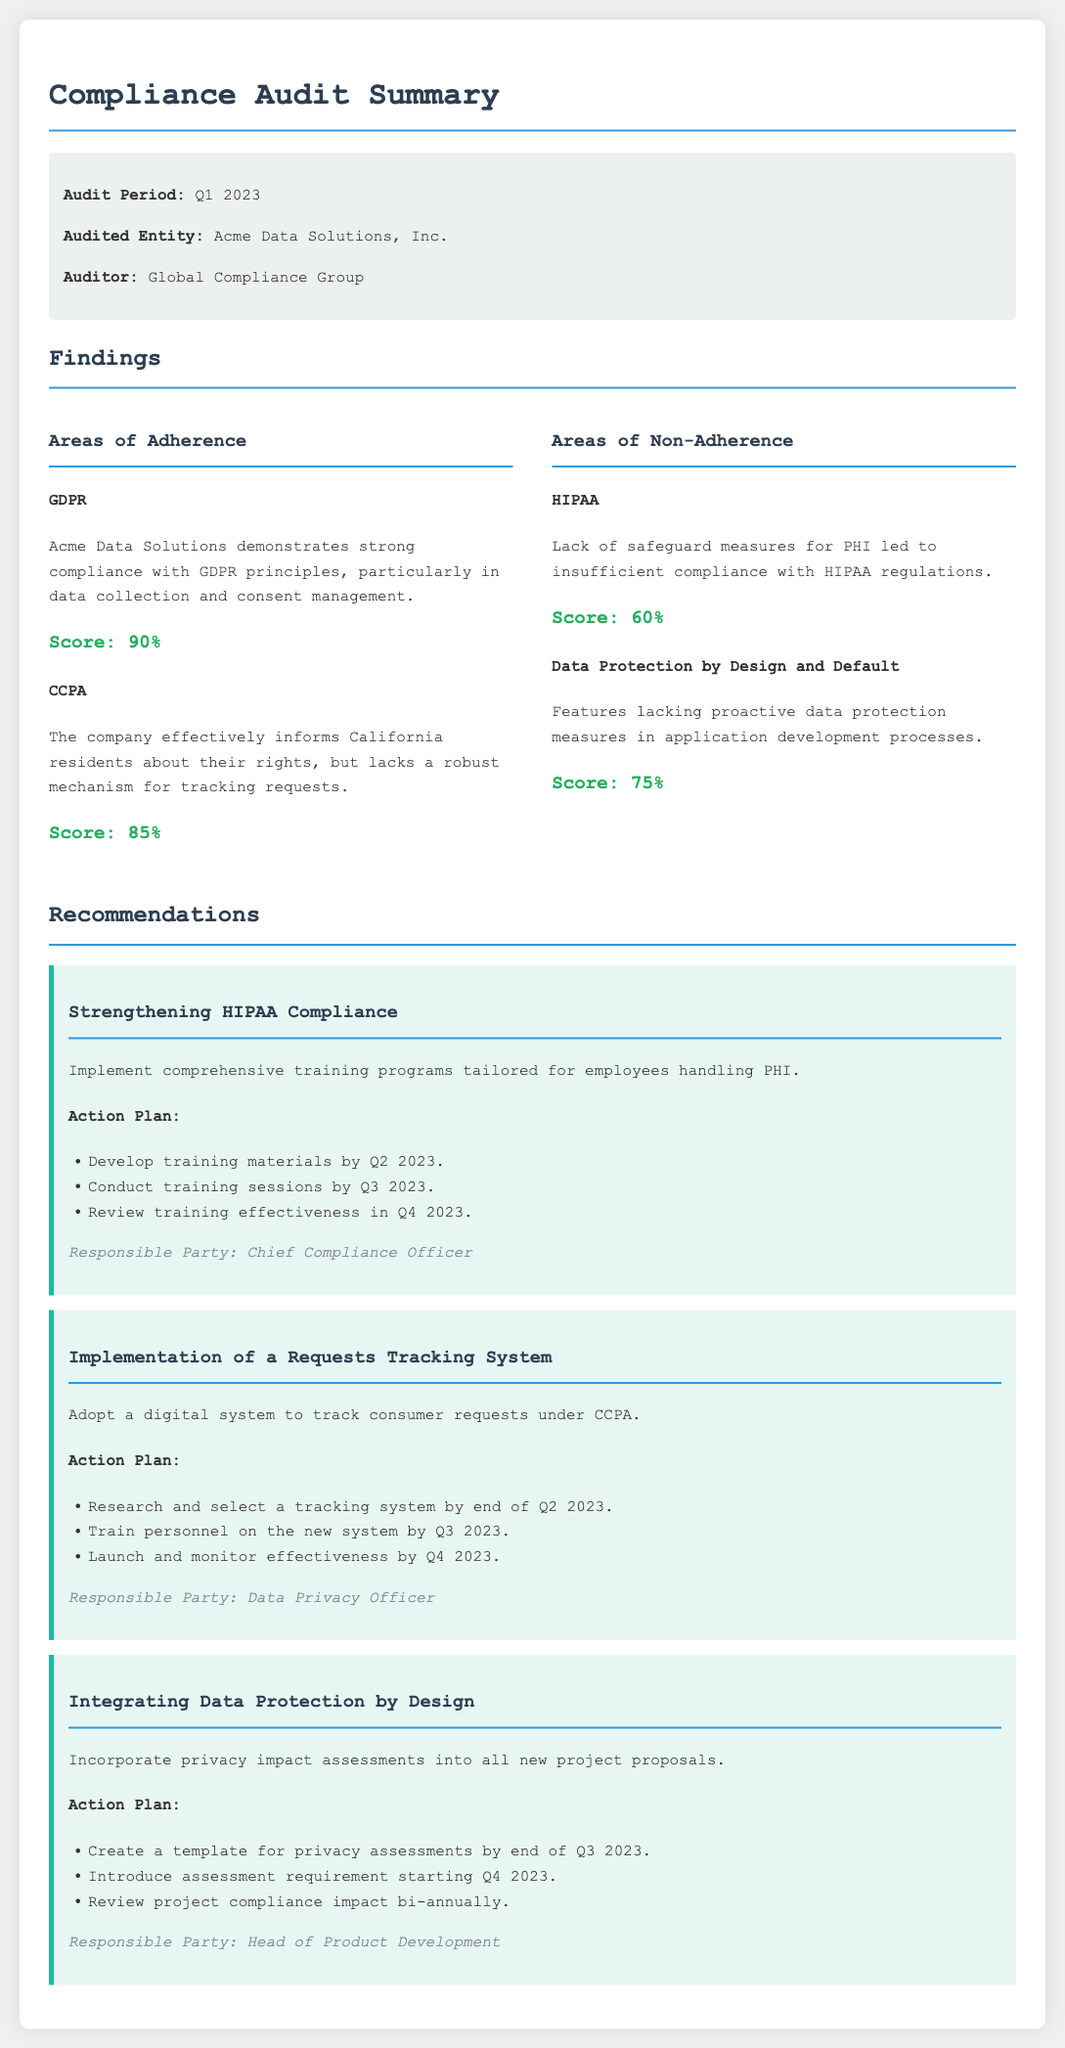What is the audit period? The audit period is specified in the document under the audit info section.
Answer: Q1 2023 Who conducted the audit? The name of the auditing entity is mentioned in the audit info section of the document.
Answer: Global Compliance Group What is the score for GDPR compliance? The score for GDPR is listed in the adherence section of the findings.
Answer: 90% What recommendation is made for HIPAA compliance? Recommendations are categorized under recommendations; this answer can be found under the respective heading.
Answer: Strengthening HIPAA Compliance What percentage score does Acme Data Solutions have for Data Protection by Design and Default? The score is mentioned in the non-adherence section, indicating how well they comply.
Answer: 75% What is the responsible party for training on the new tracking system? Each recommendation lists a responsible party at the end of its action plan.
Answer: Data Privacy Officer What is the effective score for CCPA compliance? The effective score for CCPA is found in the adherence section and is indicated clearly.
Answer: 85% What is the first action plan step for integrating Data Protection by Design? The first action plan step is indicated under the action plan section of the recommendation.
Answer: Create a template for privacy assessments by end of Q3 2023 What is the audit's total number of recommendations provided in the document? The total number of recommendations is indicated by how many are listed under the recommendations section.
Answer: 3 